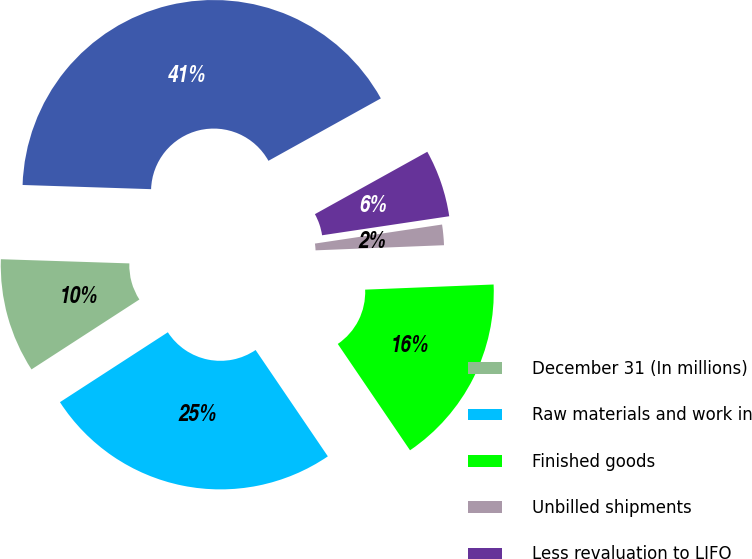Convert chart. <chart><loc_0><loc_0><loc_500><loc_500><pie_chart><fcel>December 31 (In millions)<fcel>Raw materials and work in<fcel>Finished goods<fcel>Unbilled shipments<fcel>Less revaluation to LIFO<fcel>Total<nl><fcel>9.67%<fcel>25.35%<fcel>16.14%<fcel>1.73%<fcel>5.7%<fcel>41.42%<nl></chart> 